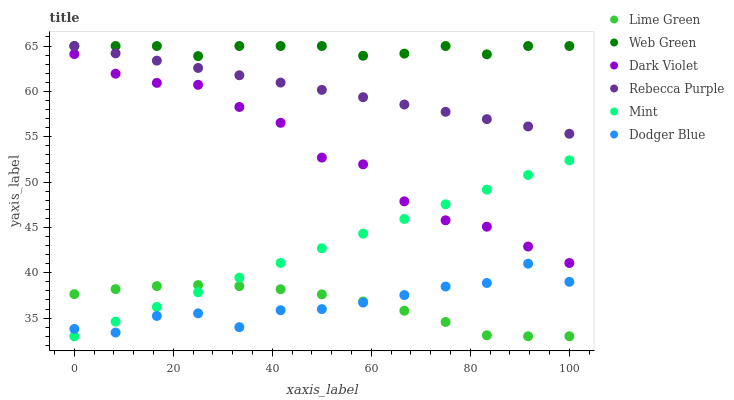Does Lime Green have the minimum area under the curve?
Answer yes or no. Yes. Does Web Green have the maximum area under the curve?
Answer yes or no. Yes. Does Dark Violet have the minimum area under the curve?
Answer yes or no. No. Does Dark Violet have the maximum area under the curve?
Answer yes or no. No. Is Mint the smoothest?
Answer yes or no. Yes. Is Dark Violet the roughest?
Answer yes or no. Yes. Is Dodger Blue the smoothest?
Answer yes or no. No. Is Dodger Blue the roughest?
Answer yes or no. No. Does Lime Green have the lowest value?
Answer yes or no. Yes. Does Dark Violet have the lowest value?
Answer yes or no. No. Does Rebecca Purple have the highest value?
Answer yes or no. Yes. Does Dark Violet have the highest value?
Answer yes or no. No. Is Lime Green less than Dark Violet?
Answer yes or no. Yes. Is Rebecca Purple greater than Lime Green?
Answer yes or no. Yes. Does Dodger Blue intersect Mint?
Answer yes or no. Yes. Is Dodger Blue less than Mint?
Answer yes or no. No. Is Dodger Blue greater than Mint?
Answer yes or no. No. Does Lime Green intersect Dark Violet?
Answer yes or no. No. 